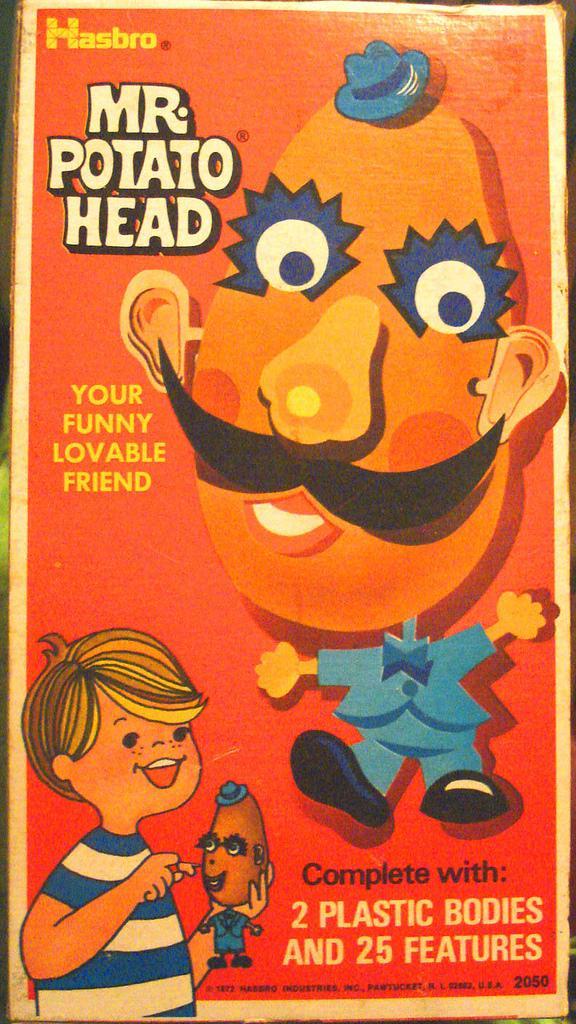Provide a one-sentence caption for the provided image. The box for the Mr. Potato Head toy from Hasbro. 